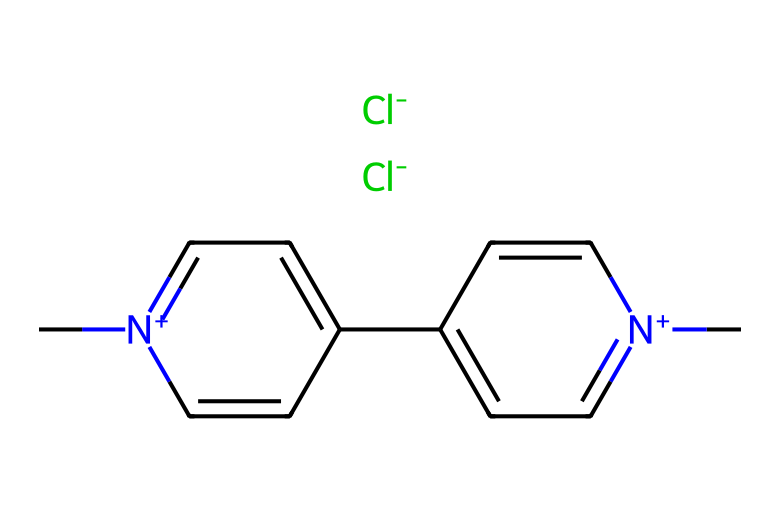What is the molecular formula of this chemical? To determine the molecular formula, we can count the different types of atoms represented in the SMILES notation. The structure includes carbon (C), nitrogen (N), and chlorine (Cl). In total, there are 12 carbon atoms, 2 nitrogen atoms, and 2 chlorine atoms. Therefore, the molecular formula is C12H14Cl2N2.
Answer: C12H14Cl2N2 How many rings are present in the structure? By analyzing the SMILES, we can see the notation indicates two distinct ring structures due to the numbers '1' appearing in the sequence. This shows that there are two rings formed in the molecular structure.
Answer: 2 What type of chemical is paraquat classified as? Given its structure and properties, paraquat is classified as a herbicide. The presence of certain nitrogen-containing groups indicates its function as a toxic herbicide used for weed control.
Answer: herbicide What functional groups are evident in the chemical structure? Observing the structure, we identify pyridinium groups, which consist of carbon and nitrogen in a cyclic arrangement, and also a quaternary ammonium structure because of the nitrogen atom with a positive charge (indicated by [n+]). This feature highlights the functional characteristics of paraquat.
Answer: pyridinium How does the presence of chlorine atoms affect the properties of paraquat? The chlorine atoms, being electronegative, increase the herbicide's stability and toxicity. They aid in the electronic characteristics of the molecule, helping it to disrupt normal cell functions in plants, thus enhancing its herbicidal activity.
Answer: increases toxicity What is the charge of the nitrogen atoms in this structure? The SMILES notation indicates that the nitrogen atoms are positively charged, as denoted by [n+]. This cationic nature affects how the molecule interacts with other substances, particularly in biological systems.
Answer: positively charged 